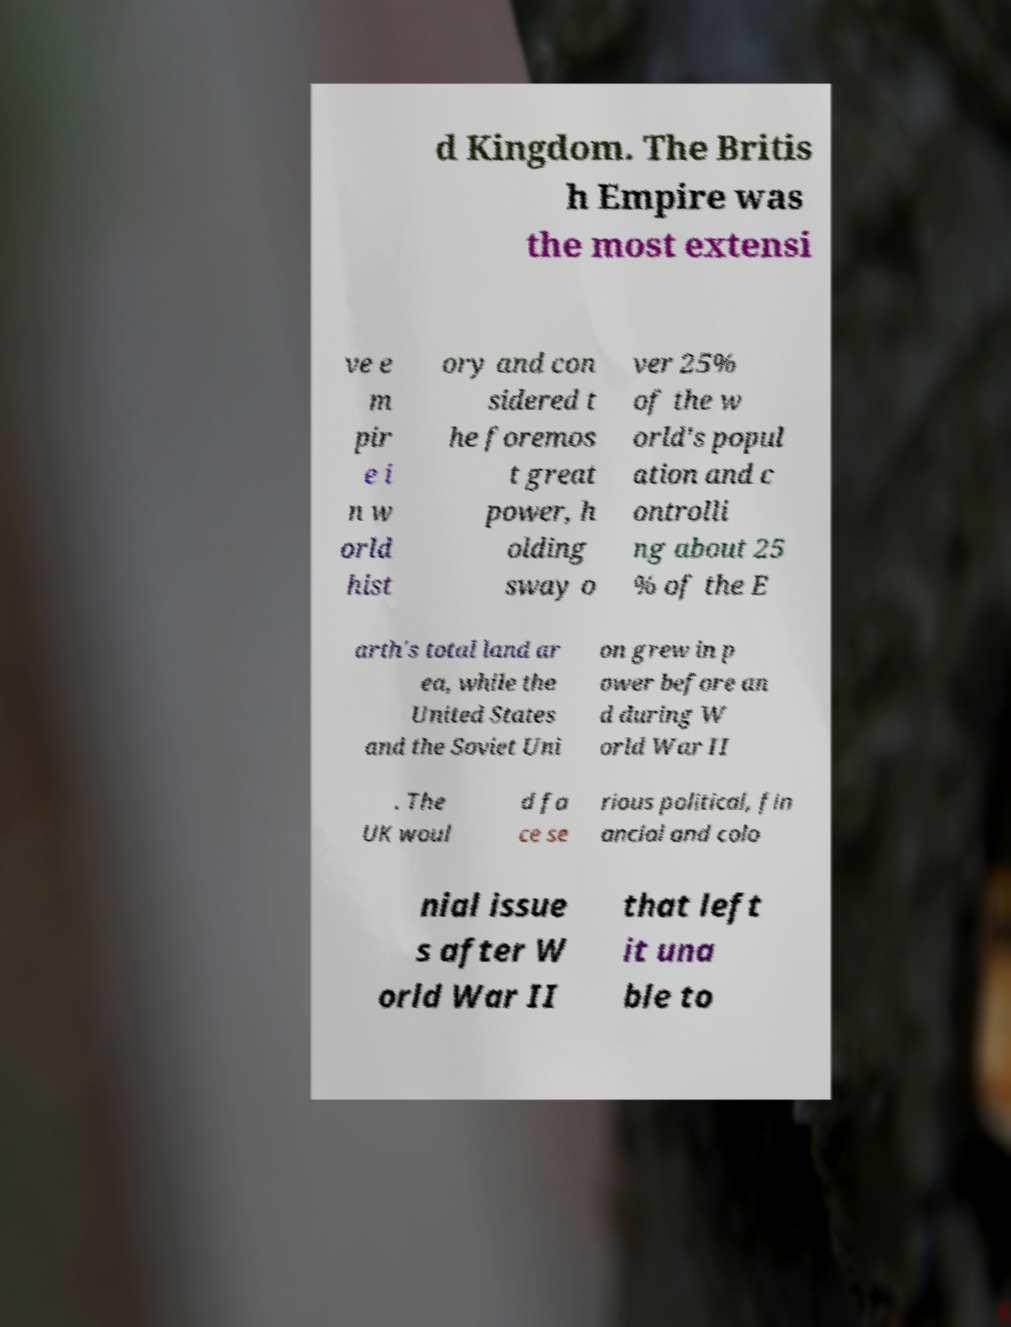Could you assist in decoding the text presented in this image and type it out clearly? d Kingdom. The Britis h Empire was the most extensi ve e m pir e i n w orld hist ory and con sidered t he foremos t great power, h olding sway o ver 25% of the w orld's popul ation and c ontrolli ng about 25 % of the E arth's total land ar ea, while the United States and the Soviet Uni on grew in p ower before an d during W orld War II . The UK woul d fa ce se rious political, fin ancial and colo nial issue s after W orld War II that left it una ble to 